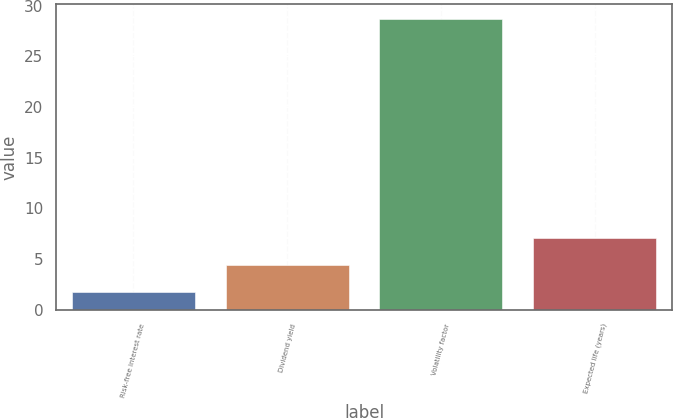<chart> <loc_0><loc_0><loc_500><loc_500><bar_chart><fcel>Risk-free interest rate<fcel>Dividend yield<fcel>Volatility factor<fcel>Expected life (years)<nl><fcel>1.71<fcel>4.41<fcel>28.68<fcel>7.11<nl></chart> 